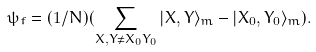<formula> <loc_0><loc_0><loc_500><loc_500>\psi _ { f } = ( 1 / N ) ( \sum _ { X , Y \neq X _ { 0 } Y _ { 0 } } | X , Y \rangle _ { m } - | X _ { 0 } , Y _ { 0 } \rangle _ { m } ) .</formula> 